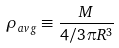<formula> <loc_0><loc_0><loc_500><loc_500>\rho _ { a v g } \equiv \frac { M } { 4 / 3 \pi R ^ { 3 } }</formula> 